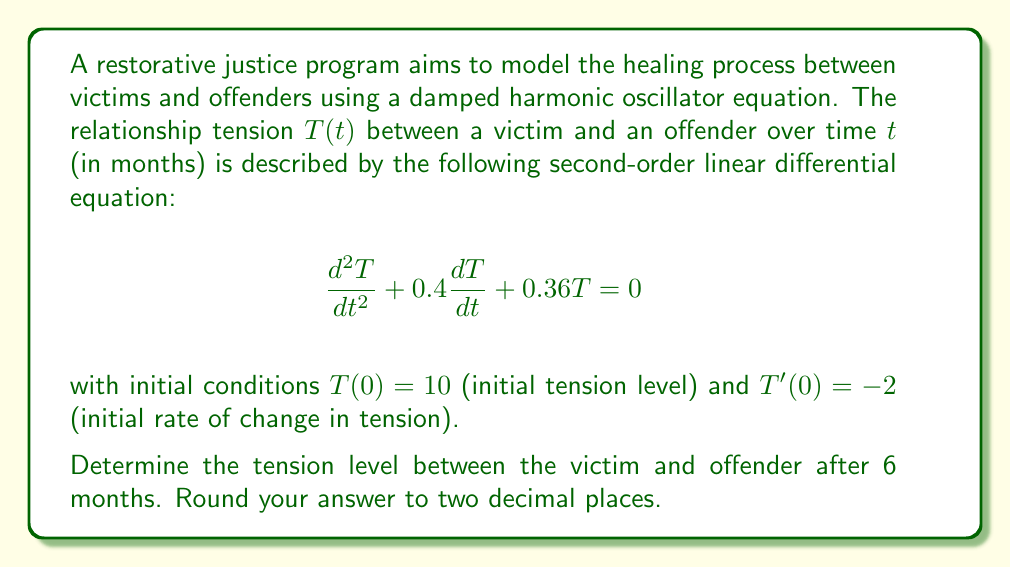What is the answer to this math problem? To solve this problem, we'll follow these steps:

1) The general solution for a damped harmonic oscillator equation of the form $\frac{d^2T}{dt^2} + 2\beta\frac{dT}{dt} + \omega_0^2T = 0$ is:

   $T(t) = e^{-\beta t}(A\cos(\omega t) + B\sin(\omega t))$

   where $\omega = \sqrt{\omega_0^2 - \beta^2}$

2) In our case, $2\beta = 0.4$, so $\beta = 0.2$, and $\omega_0^2 = 0.36$

3) Calculate $\omega$:
   $\omega = \sqrt{0.36 - 0.2^2} = \sqrt{0.32} = 0.5656854249$

4) Our solution takes the form:
   $T(t) = e^{-0.2t}(A\cos(0.5656854249t) + B\sin(0.5656854249t))$

5) Use the initial conditions to find A and B:
   $T(0) = 10$, so $A = 10$
   $T'(0) = -2$, so $-0.2A + 0.5656854249B = -2$
   Solving this, we get $B = 0.7024814731$

6) Our final solution is:
   $T(t) = e^{-0.2t}(10\cos(0.5656854249t) + 0.7024814731\sin(0.5656854249t))$

7) To find the tension after 6 months, we substitute $t = 6$ into our solution:

   $T(6) = e^{-0.2(6)}(10\cos(0.5656854249(6)) + 0.7024814731\sin(0.5656854249(6)))$

8) Calculating this (using a calculator or computer):
   $T(6) = 2.2255409284$

9) Rounding to two decimal places:
   $T(6) \approx 2.23$
Answer: 2.23 